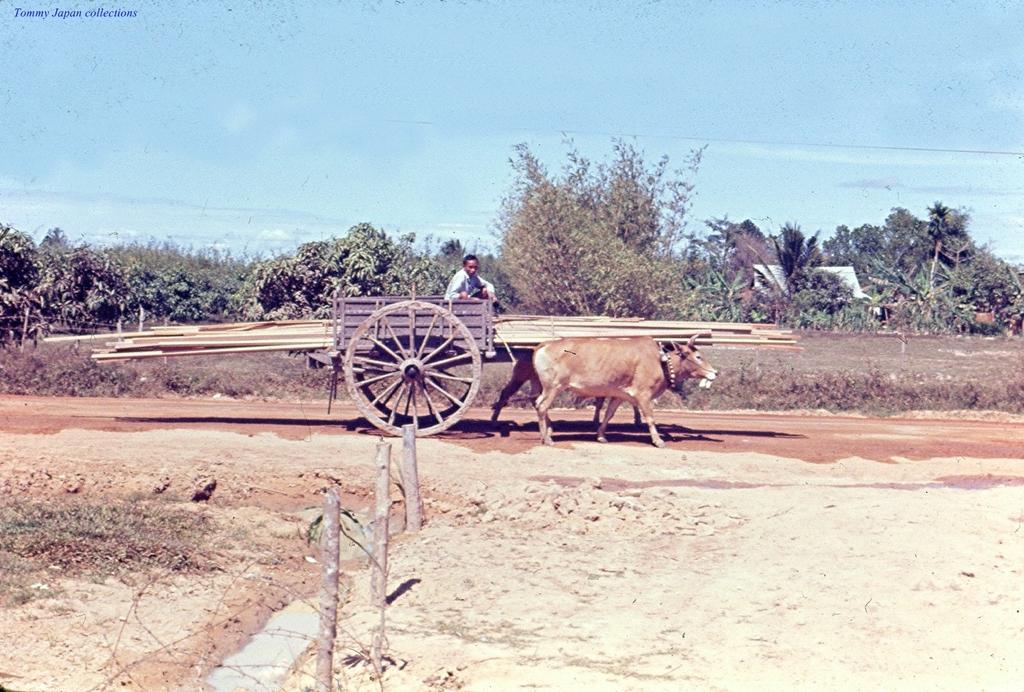Can you describe this image briefly? In this image there is the sky towards the top of the image, there is text towards the top of the image, there are trees, there are plants, there is a bullock cart, there are objects on the bullock cart, there is a man sitting on the bullock cart, there is ground towards the bottom of the image, there are wooden sticks on the ground. 